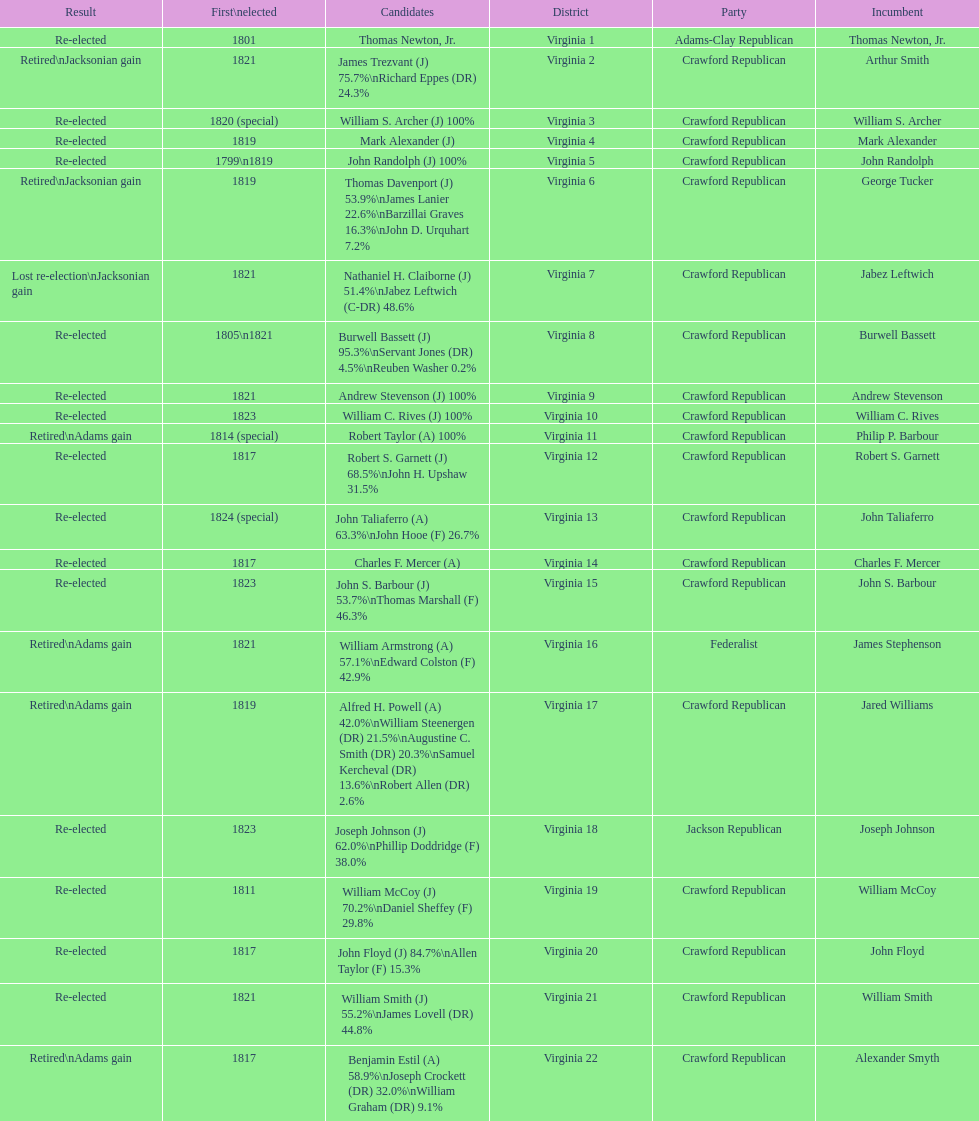Which party appears last on this chart? Crawford Republican. 